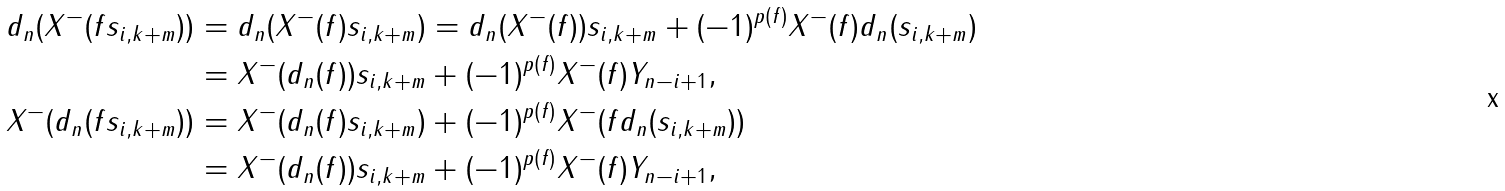Convert formula to latex. <formula><loc_0><loc_0><loc_500><loc_500>d _ { n } ( X ^ { - } ( f s _ { i , k + m } ) ) & = d _ { n } ( X ^ { - } ( f ) s _ { i , k + m } ) = d _ { n } ( X ^ { - } ( f ) ) s _ { i , k + m } + ( - 1 ) ^ { p ( f ) } X ^ { - } ( f ) d _ { n } ( s _ { i , k + m } ) \\ & = X ^ { - } ( d _ { n } ( f ) ) s _ { i , k + m } + ( - 1 ) ^ { p ( f ) } X ^ { - } ( f ) Y _ { n - i + 1 } , \\ X ^ { - } ( d _ { n } ( f s _ { i , k + m } ) ) & = X ^ { - } ( d _ { n } ( f ) s _ { i , k + m } ) + ( - 1 ) ^ { p ( f ) } X ^ { - } ( f d _ { n } ( s _ { i , k + m } ) ) \\ & = X ^ { - } ( d _ { n } ( f ) ) s _ { i , k + m } + ( - 1 ) ^ { p ( f ) } X ^ { - } ( f ) Y _ { n - i + 1 } ,</formula> 